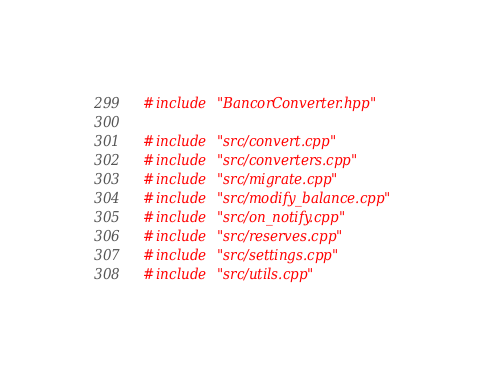<code> <loc_0><loc_0><loc_500><loc_500><_C++_>#include "BancorConverter.hpp"

#include "src/convert.cpp"
#include "src/converters.cpp"
#include "src/migrate.cpp"
#include "src/modify_balance.cpp"
#include "src/on_notify.cpp"
#include "src/reserves.cpp"
#include "src/settings.cpp"
#include "src/utils.cpp"
</code> 